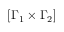Convert formula to latex. <formula><loc_0><loc_0><loc_500><loc_500>[ \Gamma _ { 1 } \times \Gamma _ { 2 } ]</formula> 